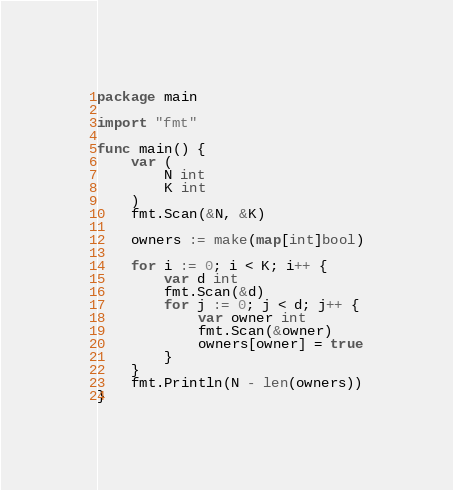Convert code to text. <code><loc_0><loc_0><loc_500><loc_500><_Go_>package main

import "fmt"

func main() {
	var (
		N int
		K int
	)
	fmt.Scan(&N, &K)

	owners := make(map[int]bool)

	for i := 0; i < K; i++ {
		var d int
		fmt.Scan(&d)
		for j := 0; j < d; j++ {
			var owner int
			fmt.Scan(&owner)
			owners[owner] = true
		}
	}
	fmt.Println(N - len(owners))
}
</code> 